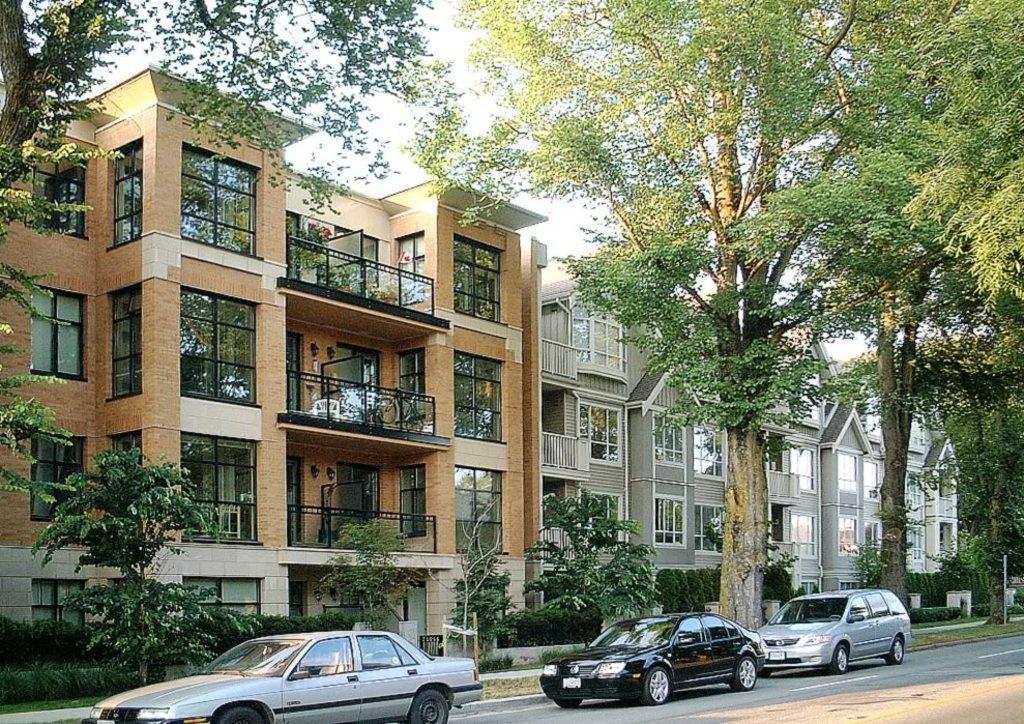Can you describe this image briefly? In this image I can see three cars on the road. I can see few trees. In the background there are few buildings. I can see the sky. 